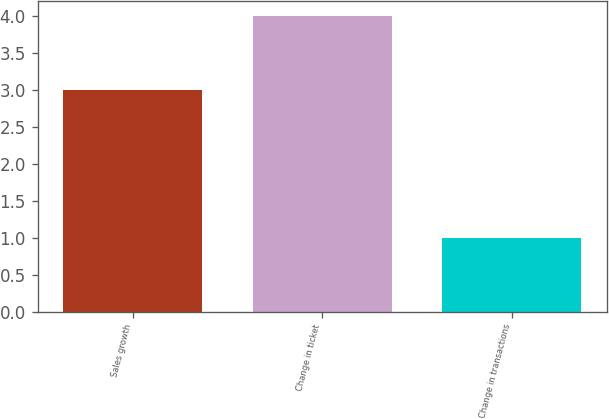Convert chart to OTSL. <chart><loc_0><loc_0><loc_500><loc_500><bar_chart><fcel>Sales growth<fcel>Change in ticket<fcel>Change in transactions<nl><fcel>3<fcel>4<fcel>1<nl></chart> 